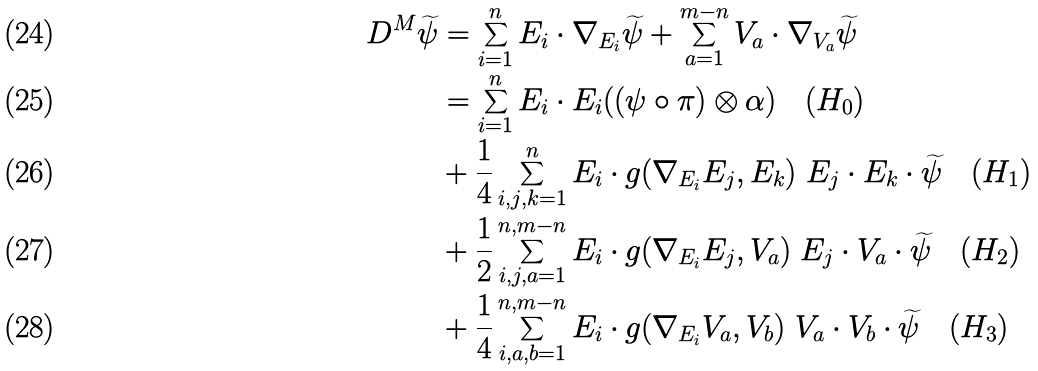<formula> <loc_0><loc_0><loc_500><loc_500>D ^ { M } \widetilde { \psi } & = \sum _ { i = 1 } ^ { n } E _ { i } \cdot \nabla _ { E _ { i } } \widetilde { \psi } + \sum _ { a = 1 } ^ { m - n } V _ { a } \cdot \nabla _ { V _ { a } } \widetilde { \psi } \\ & = \sum _ { i = 1 } ^ { n } E _ { i } \cdot E _ { i } ( ( \psi \circ \pi ) \otimes \alpha ) \quad ( H _ { 0 } ) \\ & + \frac { 1 } { 4 } \sum _ { i , j , k = 1 } ^ { n } E _ { i } \cdot g ( \nabla _ { E _ { i } } E _ { j } , E _ { k } ) \ E _ { j } \cdot E _ { k } \cdot \widetilde { \psi } \quad ( H _ { 1 } ) \\ & + \frac { 1 } { 2 } \sum _ { i , j , a = 1 } ^ { n , m - n } E _ { i } \cdot g ( \nabla _ { E _ { i } } E _ { j } , V _ { a } ) \ E _ { j } \cdot V _ { a } \cdot \widetilde { \psi } \quad ( H _ { 2 } ) \\ & + \frac { 1 } { 4 } \sum _ { i , a , b = 1 } ^ { n , m - n } E _ { i } \cdot g ( \nabla _ { E _ { i } } V _ { a } , V _ { b } ) \ V _ { a } \cdot V _ { b } \cdot \widetilde { \psi } \quad ( H _ { 3 } )</formula> 